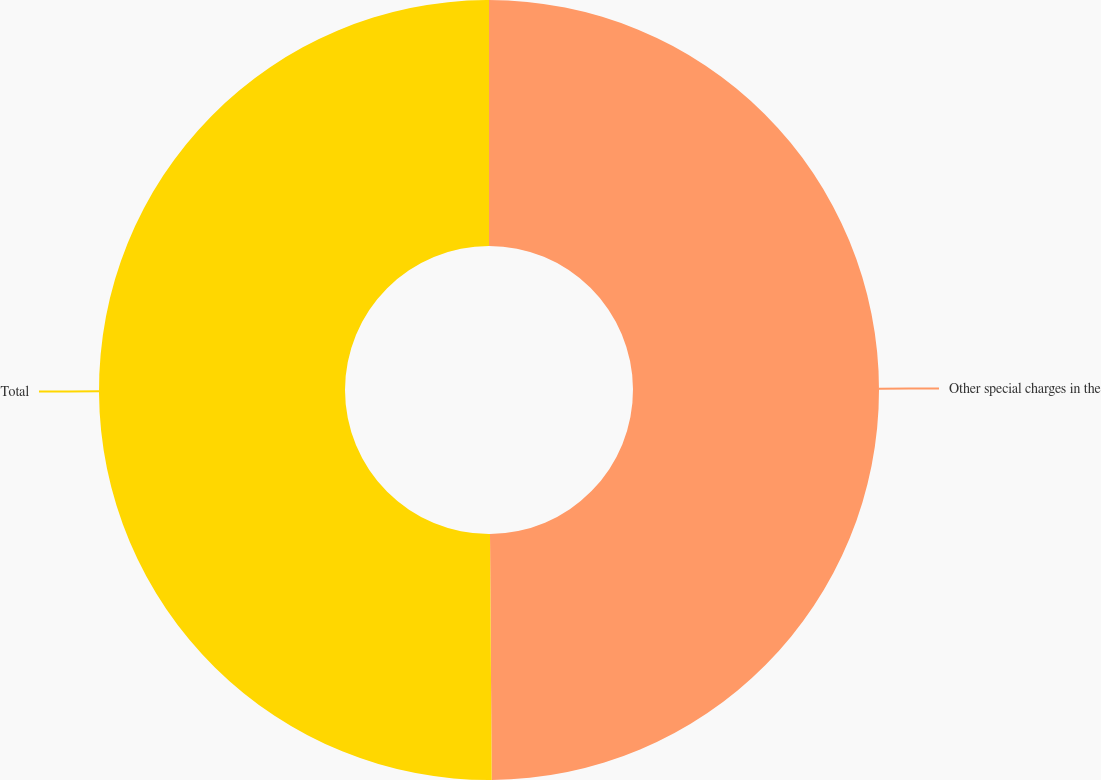<chart> <loc_0><loc_0><loc_500><loc_500><pie_chart><fcel>Other special charges in the<fcel>Total<nl><fcel>49.89%<fcel>50.11%<nl></chart> 